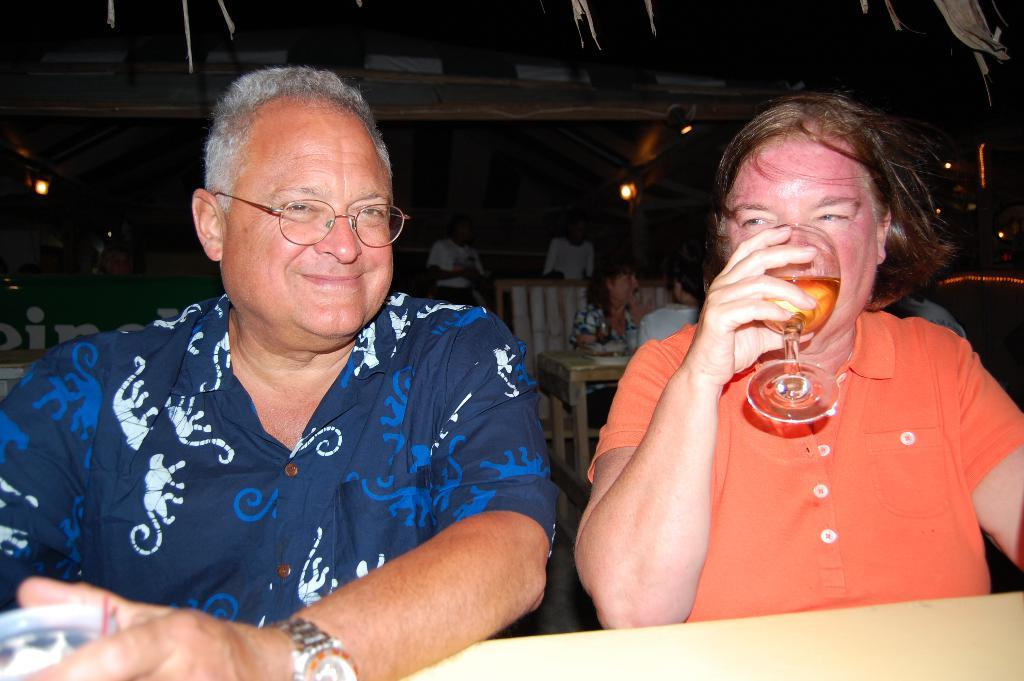How many people are sitting in the image? There are two people sitting in the image. What is one of the people doing in the image? One person is drinking wine from a wine glass. Can you describe the background of the image? There are multiple people sitting in the background of the image. What type of fan is being used by the person sitting in the image? There is no fan present in the image. How does the person sitting in the image plan to use their rake? There is no rake present in the image. 